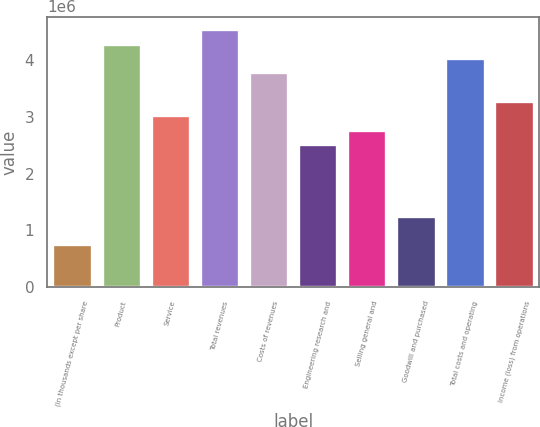Convert chart. <chart><loc_0><loc_0><loc_500><loc_500><bar_chart><fcel>(In thousands except per share<fcel>Product<fcel>Service<fcel>Total revenues<fcel>Costs of revenues<fcel>Engineering research and<fcel>Selling general and<fcel>Goodwill and purchased<fcel>Total costs and operating<fcel>Income (loss) from operations<nl><fcel>756515<fcel>4.28692e+06<fcel>3.02606e+06<fcel>4.53909e+06<fcel>3.78257e+06<fcel>2.52172e+06<fcel>2.77389e+06<fcel>1.26086e+06<fcel>4.03475e+06<fcel>3.27823e+06<nl></chart> 